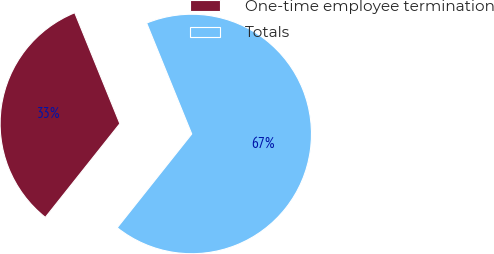<chart> <loc_0><loc_0><loc_500><loc_500><pie_chart><fcel>One-time employee termination<fcel>Totals<nl><fcel>33.16%<fcel>66.84%<nl></chart> 